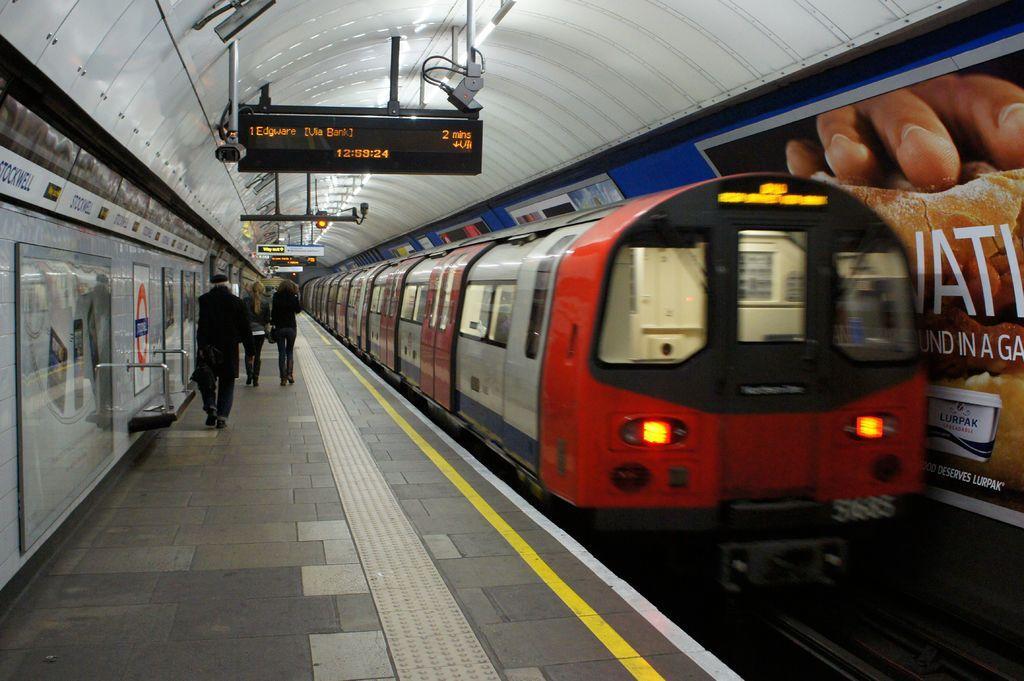Can you describe this image briefly? In this image we can see trains on the tracks, persons walking on the platforms, name boards, sign boards, advertisements and signal lights. 